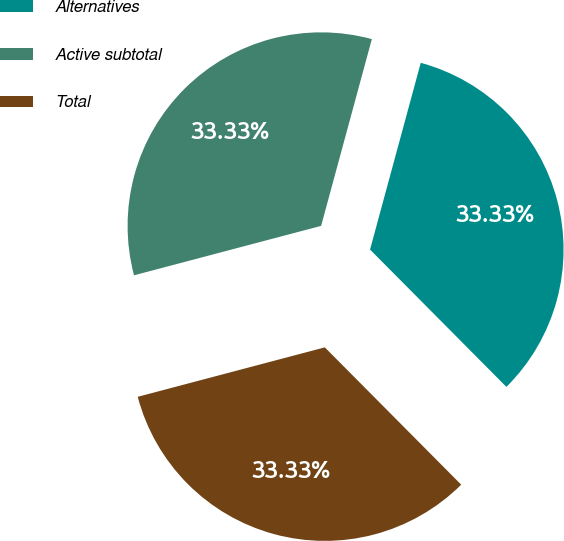Convert chart to OTSL. <chart><loc_0><loc_0><loc_500><loc_500><pie_chart><fcel>Alternatives<fcel>Active subtotal<fcel>Total<nl><fcel>33.33%<fcel>33.33%<fcel>33.33%<nl></chart> 